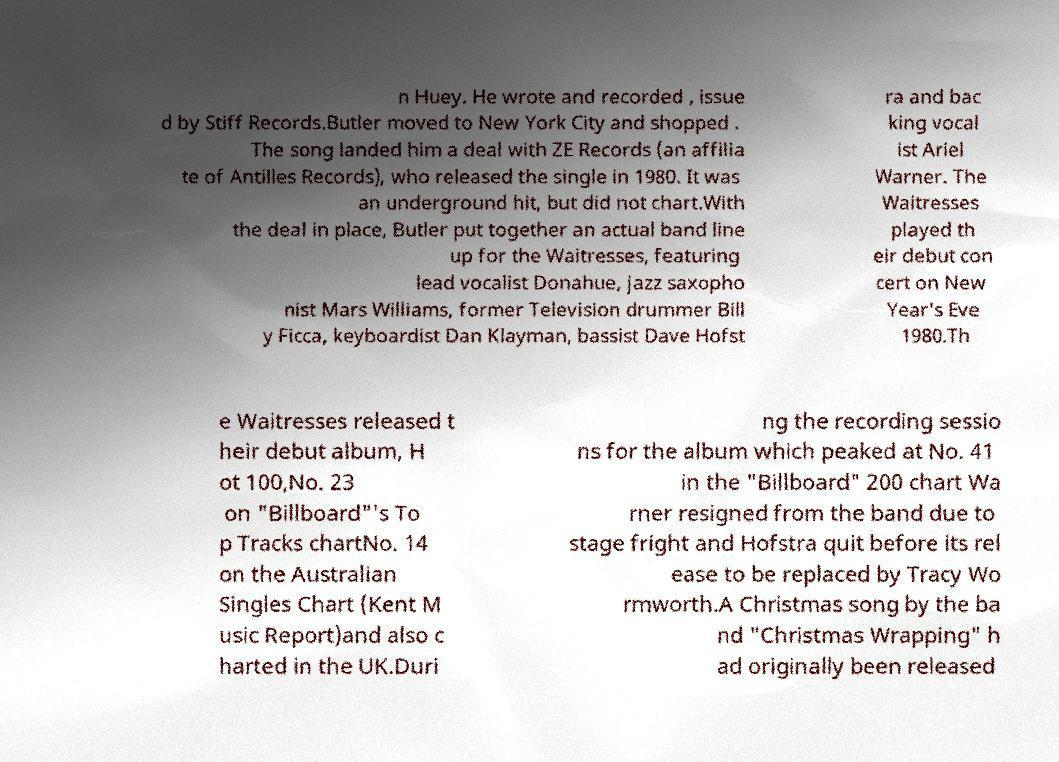Can you read and provide the text displayed in the image?This photo seems to have some interesting text. Can you extract and type it out for me? n Huey. He wrote and recorded , issue d by Stiff Records.Butler moved to New York City and shopped . The song landed him a deal with ZE Records (an affilia te of Antilles Records), who released the single in 1980. It was an underground hit, but did not chart.With the deal in place, Butler put together an actual band line up for the Waitresses, featuring lead vocalist Donahue, jazz saxopho nist Mars Williams, former Television drummer Bill y Ficca, keyboardist Dan Klayman, bassist Dave Hofst ra and bac king vocal ist Ariel Warner. The Waitresses played th eir debut con cert on New Year's Eve 1980.Th e Waitresses released t heir debut album, H ot 100,No. 23 on "Billboard"'s To p Tracks chartNo. 14 on the Australian Singles Chart (Kent M usic Report)and also c harted in the UK.Duri ng the recording sessio ns for the album which peaked at No. 41 in the "Billboard" 200 chart Wa rner resigned from the band due to stage fright and Hofstra quit before its rel ease to be replaced by Tracy Wo rmworth.A Christmas song by the ba nd "Christmas Wrapping" h ad originally been released 